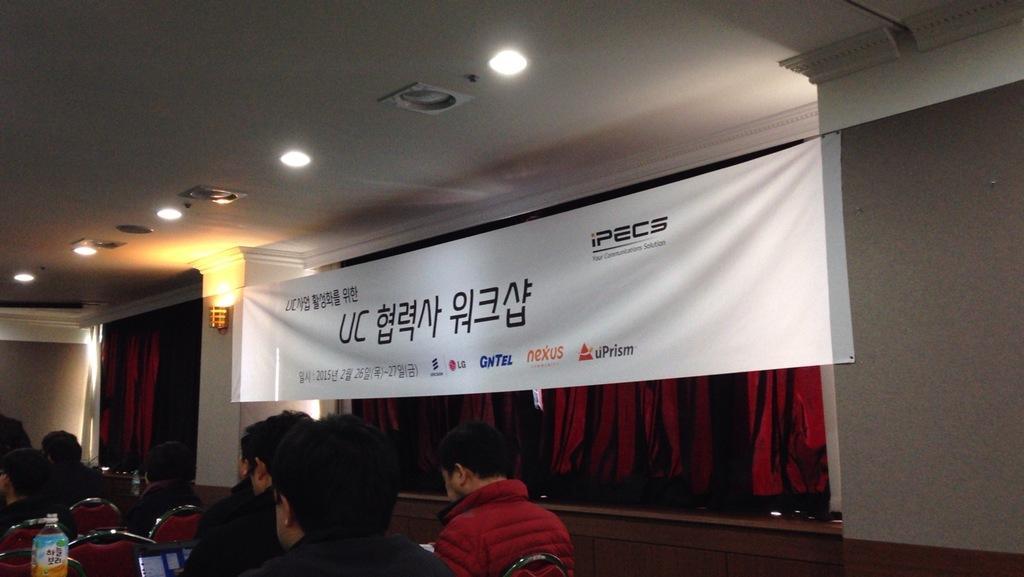Could you give a brief overview of what you see in this image? In this image we can see some people sitting on the chairs. Image also consists of a banner which is attached to the wall and also we can see the curtains. At the top there is ceiling with some ceiling lights. 